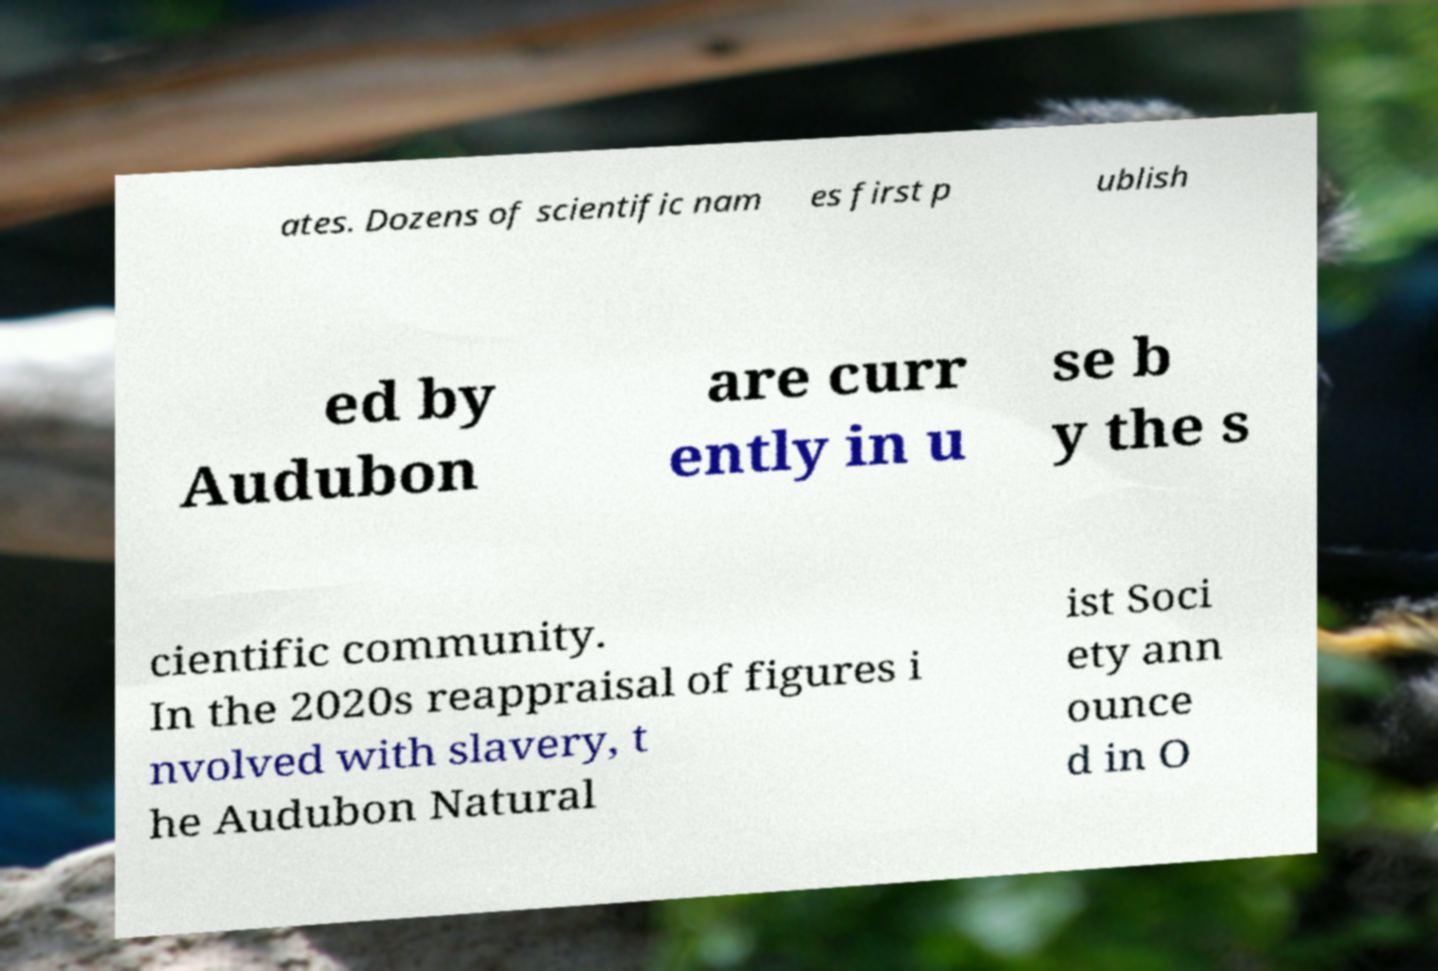There's text embedded in this image that I need extracted. Can you transcribe it verbatim? ates. Dozens of scientific nam es first p ublish ed by Audubon are curr ently in u se b y the s cientific community. In the 2020s reappraisal of figures i nvolved with slavery, t he Audubon Natural ist Soci ety ann ounce d in O 